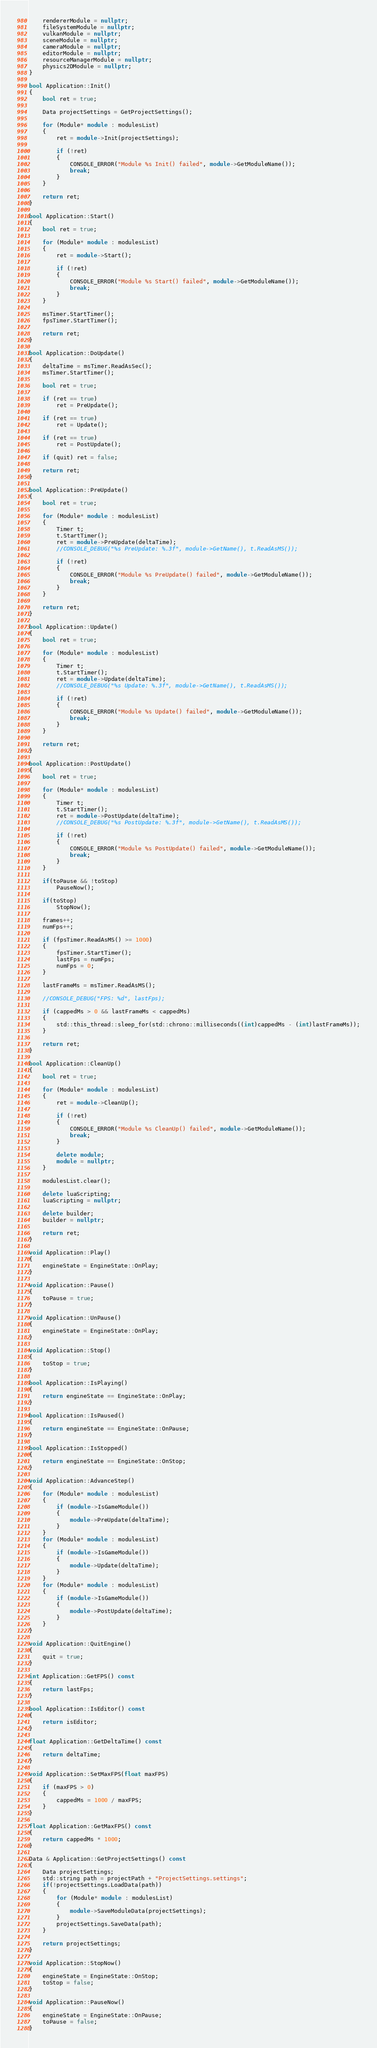Convert code to text. <code><loc_0><loc_0><loc_500><loc_500><_C++_>	rendererModule = nullptr;
	fileSystemModule = nullptr;
	vulkanModule = nullptr;
	sceneModule = nullptr;
	cameraModule = nullptr;
	editorModule = nullptr;
	resourceManagerModule = nullptr;
	physics2DModule = nullptr;
}

bool Application::Init()
{
	bool ret = true;

	Data projectSettings = GetProjectSettings();

	for (Module* module : modulesList)
	{
		ret = module->Init(projectSettings);

		if (!ret)
		{
			CONSOLE_ERROR("Module %s Init() failed", module->GetModuleName());
			break;
		}
	}

	return ret;
}

bool Application::Start()
{
	bool ret = true;

	for (Module* module : modulesList)
	{
		ret = module->Start();
		
		if (!ret)
		{
			CONSOLE_ERROR("Module %s Start() failed", module->GetModuleName());
			break;
		}
	}

	msTimer.StartTimer();
	fpsTimer.StartTimer();

	return ret;
}

bool Application::DoUpdate()
{
	deltaTime = msTimer.ReadAsSec();
	msTimer.StartTimer();

	bool ret = true;

	if (ret == true)
		ret = PreUpdate();

	if (ret == true)
		ret = Update();

	if (ret == true)
		ret = PostUpdate();

	if (quit) ret = false;

	return ret;
}

bool Application::PreUpdate()
{
	bool ret = true;

	for (Module* module : modulesList)
	{
		Timer t;
		t.StartTimer();
		ret = module->PreUpdate(deltaTime);
		//CONSOLE_DEBUG("%s PreUpdate: %.3f", module->GetName(), t.ReadAsMS());
		
		if (!ret)
		{
			CONSOLE_ERROR("Module %s PreUpdate() failed", module->GetModuleName());
			break;
		}
	}

	return ret;
}

bool Application::Update()
{
	bool ret = true;

	for (Module* module : modulesList)
	{
		Timer t;
		t.StartTimer();
		ret = module->Update(deltaTime);
		//CONSOLE_DEBUG("%s Update: %.3f", module->GetName(), t.ReadAsMS());

		if (!ret)
		{
			CONSOLE_ERROR("Module %s Update() failed", module->GetModuleName());
			break;
		}
	}

	return ret;
}

bool Application::PostUpdate()
{
	bool ret = true;

	for (Module* module : modulesList)
	{
		Timer t;
		t.StartTimer();
		ret = module->PostUpdate(deltaTime);
		//CONSOLE_DEBUG("%s PostUpdate: %.3f", module->GetName(), t.ReadAsMS());

		if (!ret)
		{
			CONSOLE_ERROR("Module %s PostUpdate() failed", module->GetModuleName());
			break;
		}
	}

	if(toPause && !toStop)
		PauseNow();

	if(toStop)
		StopNow();

	frames++;
	numFps++;

	if (fpsTimer.ReadAsMS() >= 1000)
	{
		fpsTimer.StartTimer();
		lastFps = numFps;
		numFps = 0;
	}

	lastFrameMs = msTimer.ReadAsMS();

	//CONSOLE_DEBUG("FPS: %d", lastFps);

	if (cappedMs > 0 && lastFrameMs < cappedMs)
	{
		std::this_thread::sleep_for(std::chrono::milliseconds((int)cappedMs - (int)lastFrameMs));
	}

	return ret;
}

bool Application::CleanUp()
{
	bool ret = true;

	for (Module* module : modulesList)
	{
		ret = module->CleanUp();
		
		if (!ret)
		{
			CONSOLE_ERROR("Module %s CleanUp() failed", module->GetModuleName());
			break;
		}

		delete module;
		module = nullptr;
	}

	modulesList.clear();

	delete luaScripting;
	luaScripting = nullptr;

	delete builder;
	builder = nullptr;

	return ret;
}

void Application::Play()
{
	engineState = EngineState::OnPlay;
}

void Application::Pause()
{
	toPause = true;
}

void Application::UnPause()
{
	engineState = EngineState::OnPlay;
}

void Application::Stop()
{
	toStop = true;
}

bool Application::IsPlaying()
{
	return engineState == EngineState::OnPlay;
}

bool Application::IsPaused()
{
	return engineState == EngineState::OnPause;
}

bool Application::IsStopped()
{
	return engineState == EngineState::OnStop;
}

void Application::AdvanceStep()
{
	for (Module* module : modulesList)
	{
		if (module->IsGameModule())
		{
			module->PreUpdate(deltaTime);
		}
	}
	for (Module* module : modulesList)
	{
		if (module->IsGameModule())
		{
			module->Update(deltaTime);
		}
	}
	for (Module* module : modulesList)
	{
		if (module->IsGameModule())
		{
			module->PostUpdate(deltaTime);
		}
	}
}

void Application::QuitEngine()
{
	quit = true;
}

int Application::GetFPS() const
{
	return lastFps;
}

bool Application::IsEditor() const
{
	return isEditor;
}

float Application::GetDeltaTime() const
{
	return deltaTime;
}

void Application::SetMaxFPS(float maxFPS)
{
	if (maxFPS > 0)
	{
		cappedMs = 1000 / maxFPS;
	}
}

float Application::GetMaxFPS() const
{
	return cappedMs * 1000;
}

Data & Application::GetProjectSettings() const
{
	Data projectSettings;
	std::string path = projectPath + "ProjectSettings.settings";
	if(!projectSettings.LoadData(path))
	{
		for (Module* module : modulesList)
		{
			module->SaveModuleData(projectSettings);
		}
		projectSettings.SaveData(path);
	}

	return projectSettings;
}

void Application::StopNow()
{
	engineState = EngineState::OnStop;
	toStop = false;
}

void Application::PauseNow()
{
	engineState = EngineState::OnPause;
	toPause = false;
}
</code> 